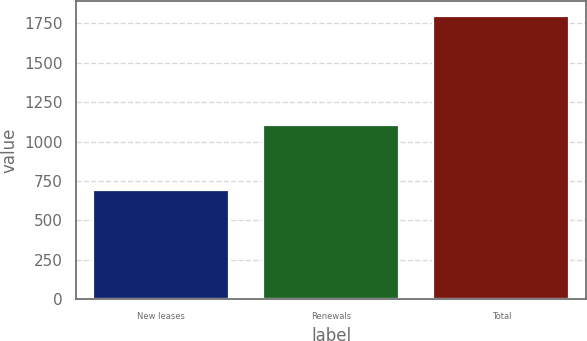Convert chart to OTSL. <chart><loc_0><loc_0><loc_500><loc_500><bar_chart><fcel>New leases<fcel>Renewals<fcel>Total<nl><fcel>695<fcel>1105<fcel>1800<nl></chart> 